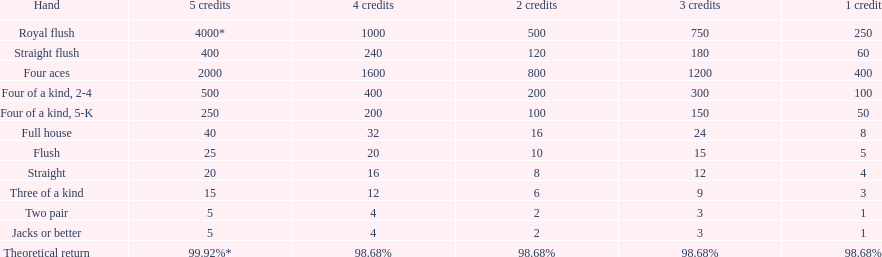Could you help me parse every detail presented in this table? {'header': ['Hand', '5 credits', '4 credits', '2 credits', '3 credits', '1 credit'], 'rows': [['Royal flush', '4000*', '1000', '500', '750', '250'], ['Straight flush', '400', '240', '120', '180', '60'], ['Four aces', '2000', '1600', '800', '1200', '400'], ['Four of a kind, 2-4', '500', '400', '200', '300', '100'], ['Four of a kind, 5-K', '250', '200', '100', '150', '50'], ['Full house', '40', '32', '16', '24', '8'], ['Flush', '25', '20', '10', '15', '5'], ['Straight', '20', '16', '8', '12', '4'], ['Three of a kind', '15', '12', '6', '9', '3'], ['Two pair', '5', '4', '2', '3', '1'], ['Jacks or better', '5', '4', '2', '3', '1'], ['Theoretical return', '99.92%*', '98.68%', '98.68%', '98.68%', '98.68%']]} Which possesses a higher status: a straight or a flush? Flush. 